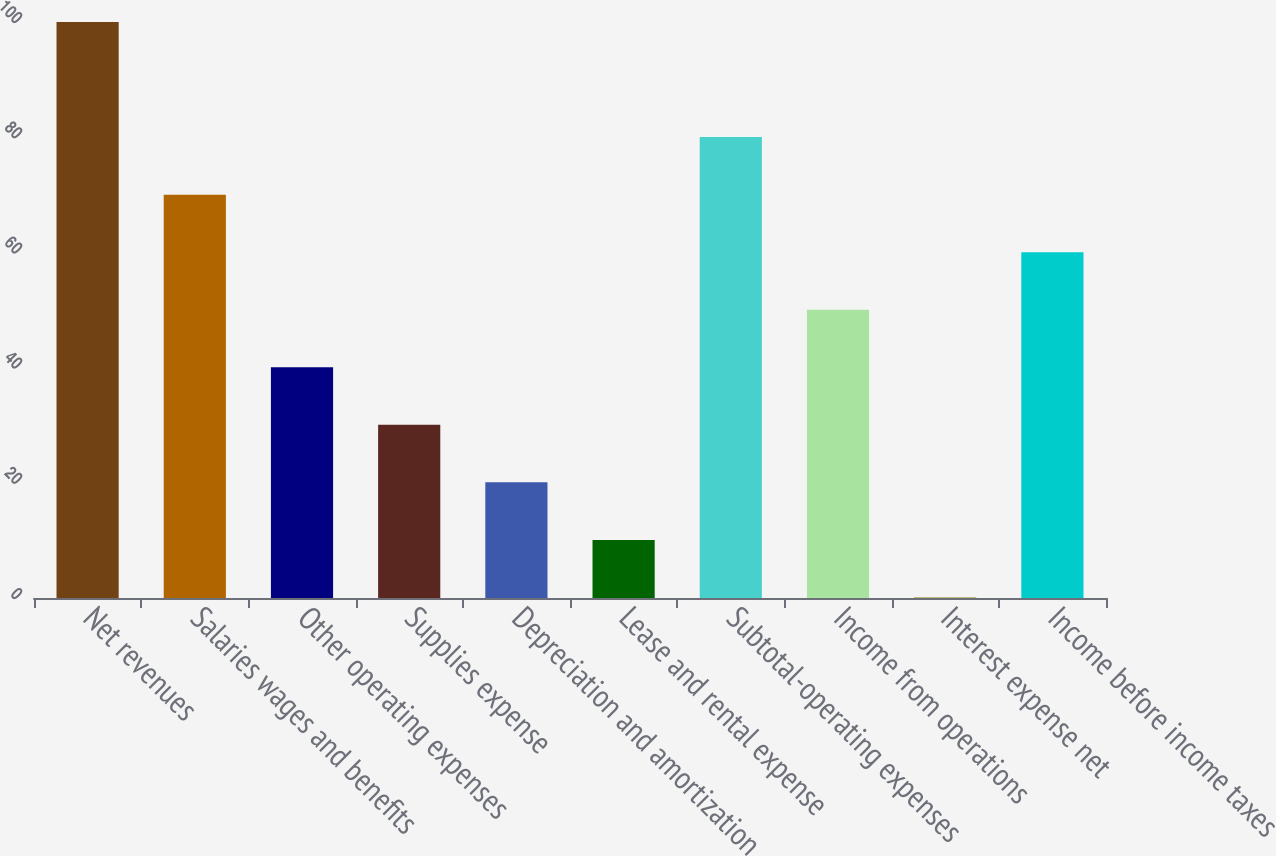Convert chart to OTSL. <chart><loc_0><loc_0><loc_500><loc_500><bar_chart><fcel>Net revenues<fcel>Salaries wages and benefits<fcel>Other operating expenses<fcel>Supplies expense<fcel>Depreciation and amortization<fcel>Lease and rental expense<fcel>Subtotal-operating expenses<fcel>Income from operations<fcel>Interest expense net<fcel>Income before income taxes<nl><fcel>100<fcel>70.03<fcel>40.06<fcel>30.07<fcel>20.08<fcel>10.09<fcel>80.02<fcel>50.05<fcel>0.1<fcel>60.04<nl></chart> 